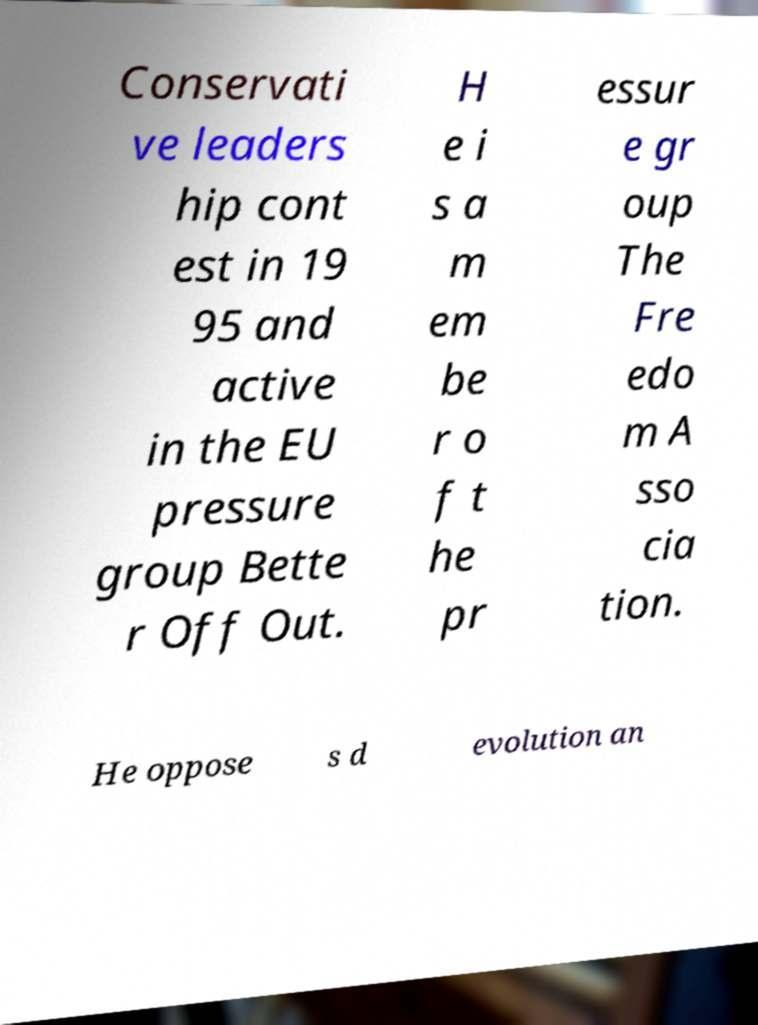I need the written content from this picture converted into text. Can you do that? Conservati ve leaders hip cont est in 19 95 and active in the EU pressure group Bette r Off Out. H e i s a m em be r o f t he pr essur e gr oup The Fre edo m A sso cia tion. He oppose s d evolution an 